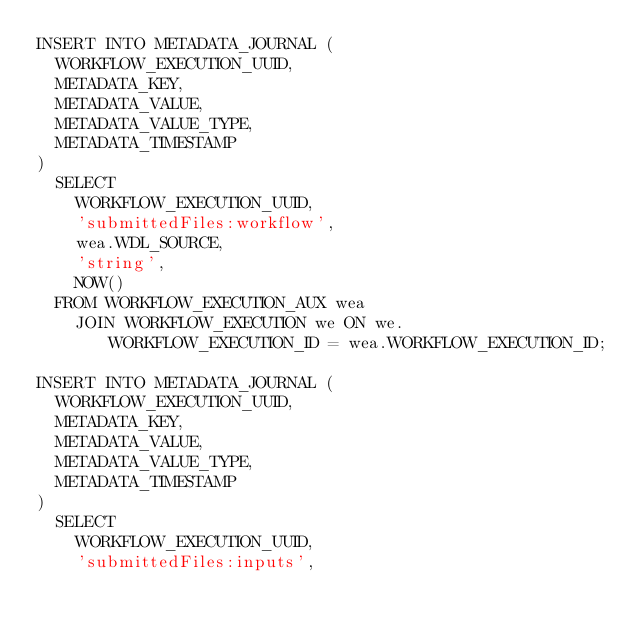<code> <loc_0><loc_0><loc_500><loc_500><_SQL_>INSERT INTO METADATA_JOURNAL (
  WORKFLOW_EXECUTION_UUID,
  METADATA_KEY,
  METADATA_VALUE,
  METADATA_VALUE_TYPE,
  METADATA_TIMESTAMP
)
  SELECT
    WORKFLOW_EXECUTION_UUID,
    'submittedFiles:workflow',
    wea.WDL_SOURCE,
    'string',
    NOW()
  FROM WORKFLOW_EXECUTION_AUX wea
    JOIN WORKFLOW_EXECUTION we ON we.WORKFLOW_EXECUTION_ID = wea.WORKFLOW_EXECUTION_ID;

INSERT INTO METADATA_JOURNAL (
  WORKFLOW_EXECUTION_UUID,
  METADATA_KEY,
  METADATA_VALUE,
  METADATA_VALUE_TYPE,
  METADATA_TIMESTAMP
)
  SELECT
    WORKFLOW_EXECUTION_UUID,
    'submittedFiles:inputs',</code> 